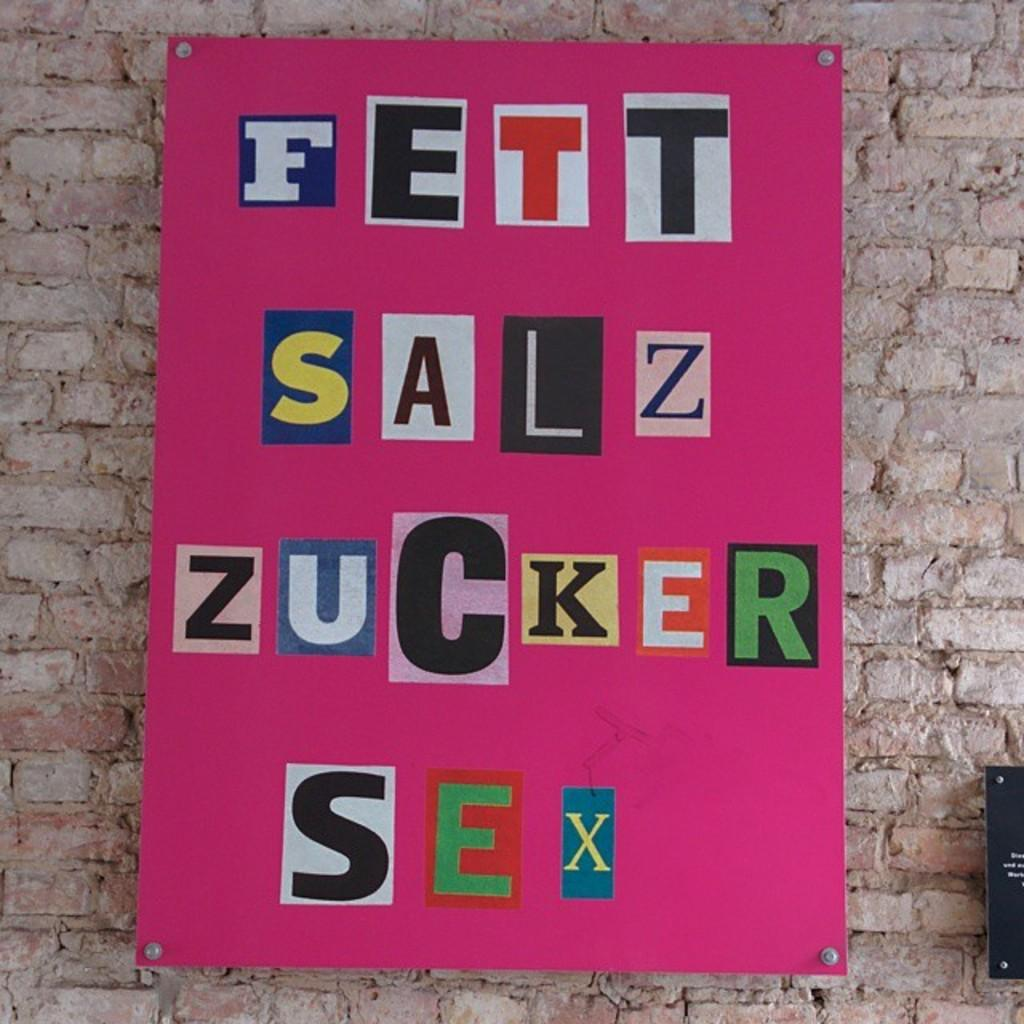<image>
Share a concise interpretation of the image provided. A bright pink sign that has cut out letters that read "FETT SALZ ZUCKER SEX" is displayed on a brick wall. 